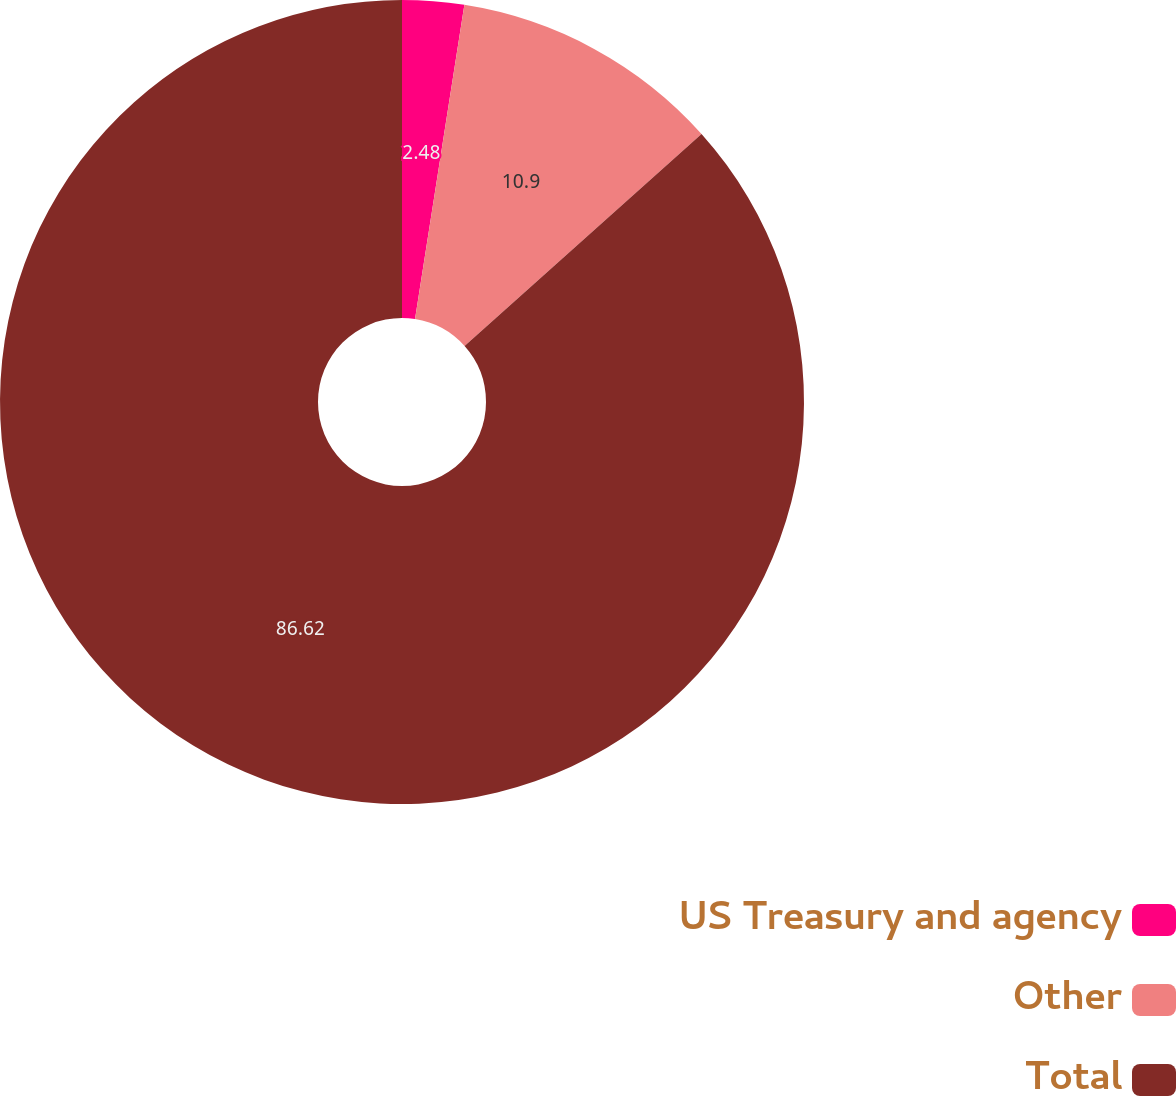<chart> <loc_0><loc_0><loc_500><loc_500><pie_chart><fcel>US Treasury and agency<fcel>Other<fcel>Total<nl><fcel>2.48%<fcel>10.9%<fcel>86.62%<nl></chart> 